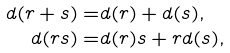Convert formula to latex. <formula><loc_0><loc_0><loc_500><loc_500>d ( r + s ) = & d ( r ) + d ( s ) , \\ \quad d ( r s ) = & d ( r ) s + r d ( s ) ,</formula> 